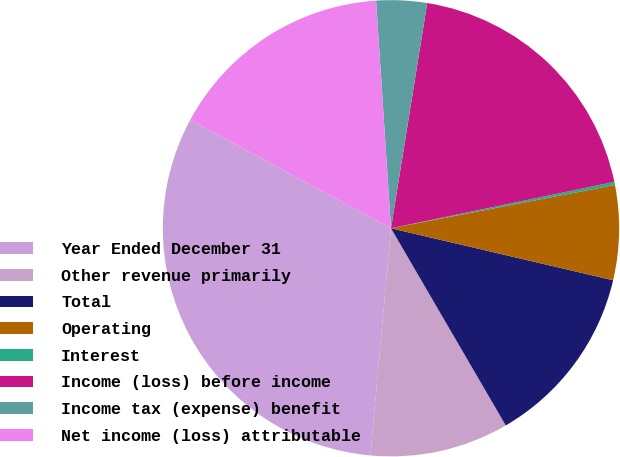Convert chart to OTSL. <chart><loc_0><loc_0><loc_500><loc_500><pie_chart><fcel>Year Ended December 31<fcel>Other revenue primarily<fcel>Total<fcel>Operating<fcel>Interest<fcel>Income (loss) before income<fcel>Income tax (expense) benefit<fcel>Net income (loss) attributable<nl><fcel>31.45%<fcel>9.83%<fcel>12.95%<fcel>6.7%<fcel>0.22%<fcel>19.2%<fcel>3.58%<fcel>16.07%<nl></chart> 